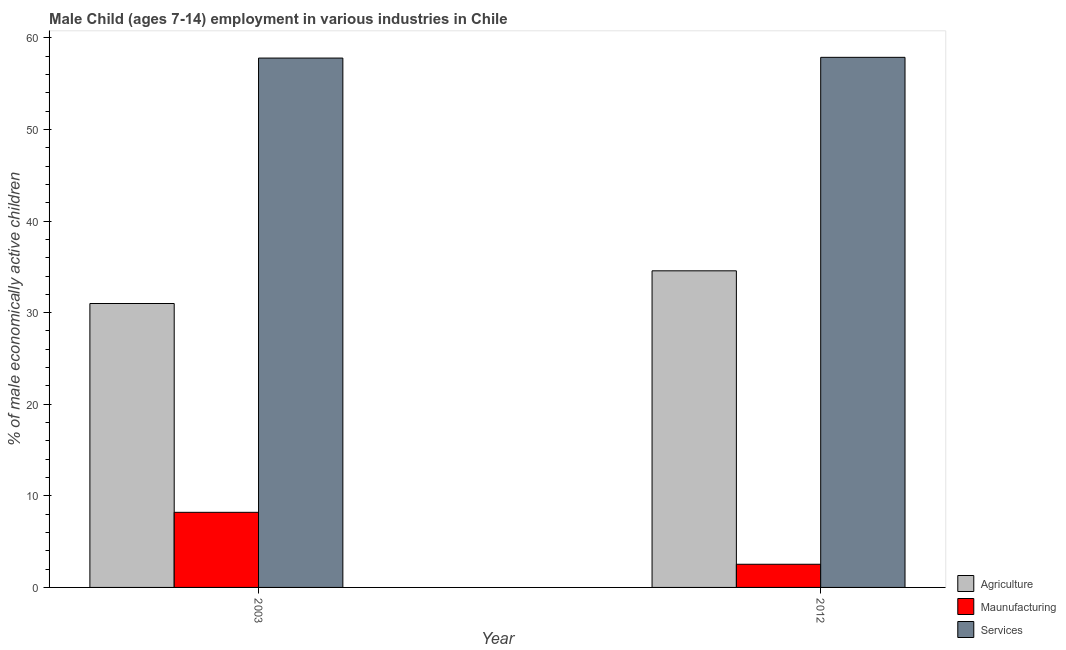Are the number of bars on each tick of the X-axis equal?
Give a very brief answer. Yes. In how many cases, is the number of bars for a given year not equal to the number of legend labels?
Keep it short and to the point. 0. What is the percentage of economically active children in manufacturing in 2003?
Make the answer very short. 8.2. Across all years, what is the maximum percentage of economically active children in services?
Your response must be concise. 57.88. Across all years, what is the minimum percentage of economically active children in manufacturing?
Ensure brevity in your answer.  2.53. In which year was the percentage of economically active children in manufacturing maximum?
Ensure brevity in your answer.  2003. What is the total percentage of economically active children in services in the graph?
Provide a succinct answer. 115.68. What is the difference between the percentage of economically active children in services in 2003 and that in 2012?
Give a very brief answer. -0.08. What is the difference between the percentage of economically active children in agriculture in 2003 and the percentage of economically active children in manufacturing in 2012?
Your answer should be very brief. -3.57. What is the average percentage of economically active children in manufacturing per year?
Offer a terse response. 5.36. In how many years, is the percentage of economically active children in manufacturing greater than 22 %?
Ensure brevity in your answer.  0. What is the ratio of the percentage of economically active children in agriculture in 2003 to that in 2012?
Your response must be concise. 0.9. In how many years, is the percentage of economically active children in manufacturing greater than the average percentage of economically active children in manufacturing taken over all years?
Your answer should be compact. 1. What does the 1st bar from the left in 2003 represents?
Your answer should be compact. Agriculture. What does the 1st bar from the right in 2012 represents?
Provide a short and direct response. Services. Is it the case that in every year, the sum of the percentage of economically active children in agriculture and percentage of economically active children in manufacturing is greater than the percentage of economically active children in services?
Offer a very short reply. No. How many bars are there?
Your response must be concise. 6. Are all the bars in the graph horizontal?
Provide a short and direct response. No. What is the difference between two consecutive major ticks on the Y-axis?
Offer a terse response. 10. Are the values on the major ticks of Y-axis written in scientific E-notation?
Ensure brevity in your answer.  No. Does the graph contain any zero values?
Your answer should be compact. No. How many legend labels are there?
Your answer should be compact. 3. How are the legend labels stacked?
Ensure brevity in your answer.  Vertical. What is the title of the graph?
Your response must be concise. Male Child (ages 7-14) employment in various industries in Chile. Does "Injury" appear as one of the legend labels in the graph?
Offer a very short reply. No. What is the label or title of the Y-axis?
Your response must be concise. % of male economically active children. What is the % of male economically active children of Agriculture in 2003?
Your answer should be compact. 31. What is the % of male economically active children of Maunufacturing in 2003?
Offer a very short reply. 8.2. What is the % of male economically active children in Services in 2003?
Offer a terse response. 57.8. What is the % of male economically active children of Agriculture in 2012?
Offer a terse response. 34.57. What is the % of male economically active children in Maunufacturing in 2012?
Your answer should be very brief. 2.53. What is the % of male economically active children in Services in 2012?
Keep it short and to the point. 57.88. Across all years, what is the maximum % of male economically active children of Agriculture?
Your answer should be very brief. 34.57. Across all years, what is the maximum % of male economically active children in Services?
Ensure brevity in your answer.  57.88. Across all years, what is the minimum % of male economically active children of Agriculture?
Your answer should be compact. 31. Across all years, what is the minimum % of male economically active children of Maunufacturing?
Your response must be concise. 2.53. Across all years, what is the minimum % of male economically active children in Services?
Your response must be concise. 57.8. What is the total % of male economically active children of Agriculture in the graph?
Give a very brief answer. 65.57. What is the total % of male economically active children of Maunufacturing in the graph?
Your answer should be very brief. 10.73. What is the total % of male economically active children of Services in the graph?
Ensure brevity in your answer.  115.68. What is the difference between the % of male economically active children of Agriculture in 2003 and that in 2012?
Offer a terse response. -3.57. What is the difference between the % of male economically active children of Maunufacturing in 2003 and that in 2012?
Ensure brevity in your answer.  5.67. What is the difference between the % of male economically active children in Services in 2003 and that in 2012?
Keep it short and to the point. -0.08. What is the difference between the % of male economically active children in Agriculture in 2003 and the % of male economically active children in Maunufacturing in 2012?
Provide a succinct answer. 28.47. What is the difference between the % of male economically active children of Agriculture in 2003 and the % of male economically active children of Services in 2012?
Offer a terse response. -26.88. What is the difference between the % of male economically active children in Maunufacturing in 2003 and the % of male economically active children in Services in 2012?
Offer a terse response. -49.68. What is the average % of male economically active children of Agriculture per year?
Provide a short and direct response. 32.78. What is the average % of male economically active children in Maunufacturing per year?
Make the answer very short. 5.37. What is the average % of male economically active children in Services per year?
Your response must be concise. 57.84. In the year 2003, what is the difference between the % of male economically active children of Agriculture and % of male economically active children of Maunufacturing?
Make the answer very short. 22.8. In the year 2003, what is the difference between the % of male economically active children in Agriculture and % of male economically active children in Services?
Provide a succinct answer. -26.8. In the year 2003, what is the difference between the % of male economically active children in Maunufacturing and % of male economically active children in Services?
Give a very brief answer. -49.6. In the year 2012, what is the difference between the % of male economically active children in Agriculture and % of male economically active children in Maunufacturing?
Offer a terse response. 32.04. In the year 2012, what is the difference between the % of male economically active children in Agriculture and % of male economically active children in Services?
Keep it short and to the point. -23.31. In the year 2012, what is the difference between the % of male economically active children in Maunufacturing and % of male economically active children in Services?
Your answer should be very brief. -55.35. What is the ratio of the % of male economically active children in Agriculture in 2003 to that in 2012?
Offer a very short reply. 0.9. What is the ratio of the % of male economically active children in Maunufacturing in 2003 to that in 2012?
Ensure brevity in your answer.  3.24. What is the difference between the highest and the second highest % of male economically active children in Agriculture?
Offer a very short reply. 3.57. What is the difference between the highest and the second highest % of male economically active children of Maunufacturing?
Provide a short and direct response. 5.67. What is the difference between the highest and the second highest % of male economically active children of Services?
Give a very brief answer. 0.08. What is the difference between the highest and the lowest % of male economically active children in Agriculture?
Offer a terse response. 3.57. What is the difference between the highest and the lowest % of male economically active children of Maunufacturing?
Make the answer very short. 5.67. What is the difference between the highest and the lowest % of male economically active children of Services?
Give a very brief answer. 0.08. 